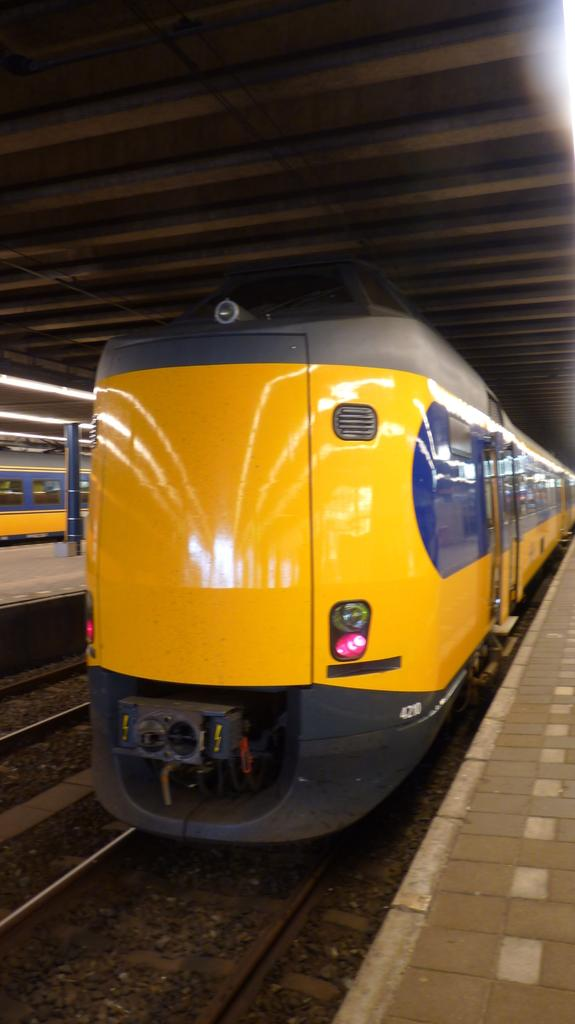What is the main subject of the image? There is a train in the image. What is the train positioned on in the image? The train is positioned on a railway track at the bottom of the image. What can be seen on the right side of the image? There is a platform on the right side of the image. What is visible in the background of the image? There are lights visible in the background of the image. What type of wren can be seen using the rake in the image? There is no wren or rake present in the image; it features a train, railway track, platform, and lights. Can you tell me how many scissors are visible on the platform in the image? There are no scissors visible on the platform in the image. 